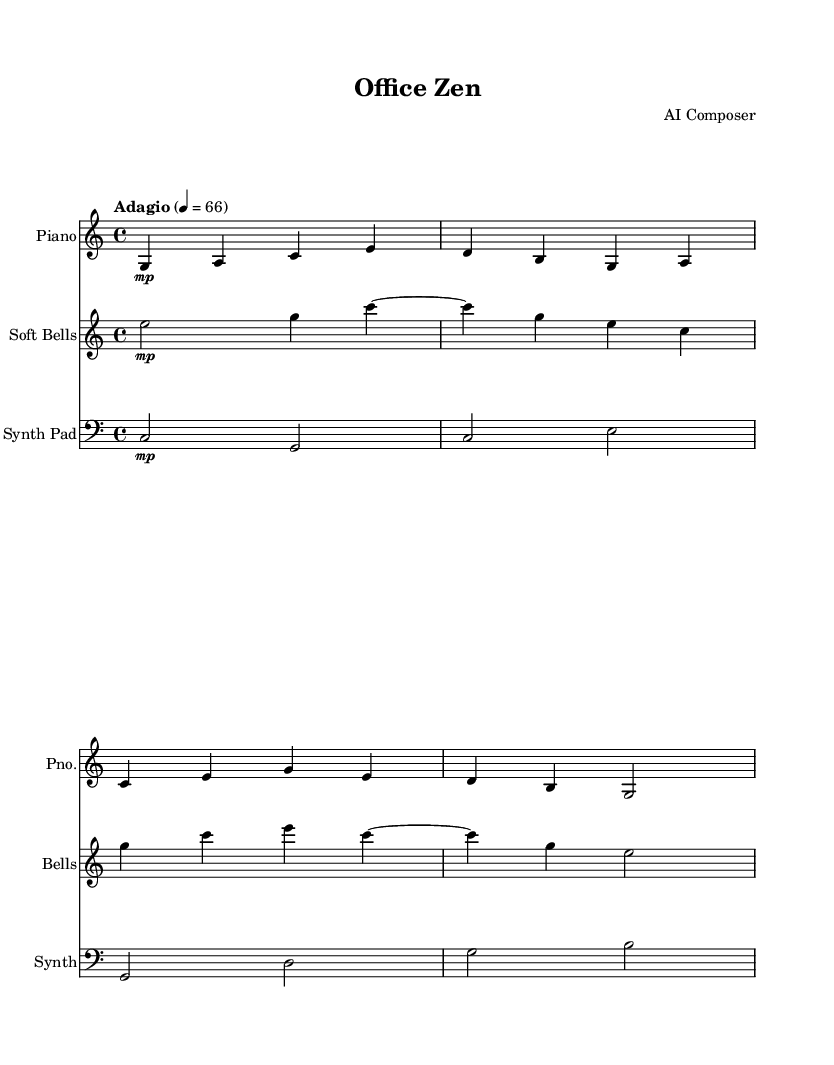What is the key signature of this music? The key signature is C major, which has no sharps or flats.
Answer: C major What is the time signature of this music? The time signature is found at the beginning of the score, indicating how many beats are in each measure. It is 4/4, meaning there are four beats per measure.
Answer: 4/4 What is the tempo marking for this piece? The tempo marking is indicated above the staff and specifies how fast the piece should be played. The marking is "Adagio," with a metronome marking of 66 beats per minute.
Answer: Adagio How many measures are in the piano part? By counting the groups of notes separated by vertical lines on the staff, we find the total number of measures played by the piano. There are four measures in total.
Answer: 4 Which instrument is playing a synth pad? The instrument name is explicitly given at the beginning of the corresponding staff. "Synth Pad" refers to the sounds produced by that instrument.
Answer: Synth What is the dynamic marking for the soft bells? The dynamic marking can be found in the dynamics section of the score for the soft bells, which is indicated as "mp," meaning "mezzo-piano" or moderately soft.
Answer: mp What is a notable characteristic of the ambiance created by this soundtrack? The music includes soft, gentle sounds that are typically designed to create a calm and focused environment, which is characteristic of ambient soundscapes meant for concentration and productivity.
Answer: Calm and focused 